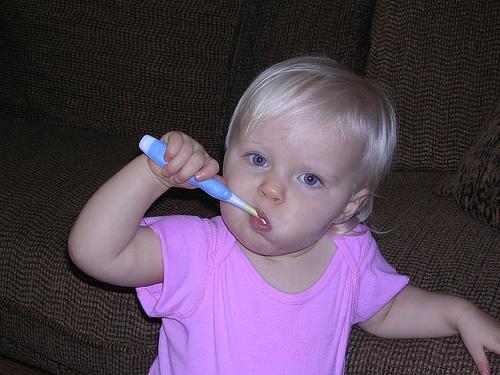Is the baby wearing pink?
Be succinct. Yes. Which is the baby's dominant hand?
Write a very short answer. Right. What is in her mouth?
Write a very short answer. Toothbrush. Is the baby in the bathroom?
Short answer required. No. 